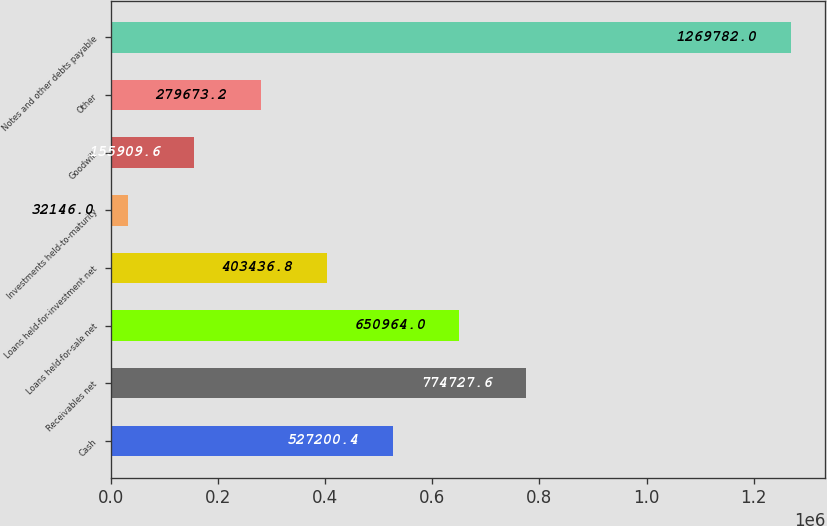<chart> <loc_0><loc_0><loc_500><loc_500><bar_chart><fcel>Cash<fcel>Receivables net<fcel>Loans held-for-sale net<fcel>Loans held-for-investment net<fcel>Investments held-to-maturity<fcel>Goodwill<fcel>Other<fcel>Notes and other debts payable<nl><fcel>527200<fcel>774728<fcel>650964<fcel>403437<fcel>32146<fcel>155910<fcel>279673<fcel>1.26978e+06<nl></chart> 